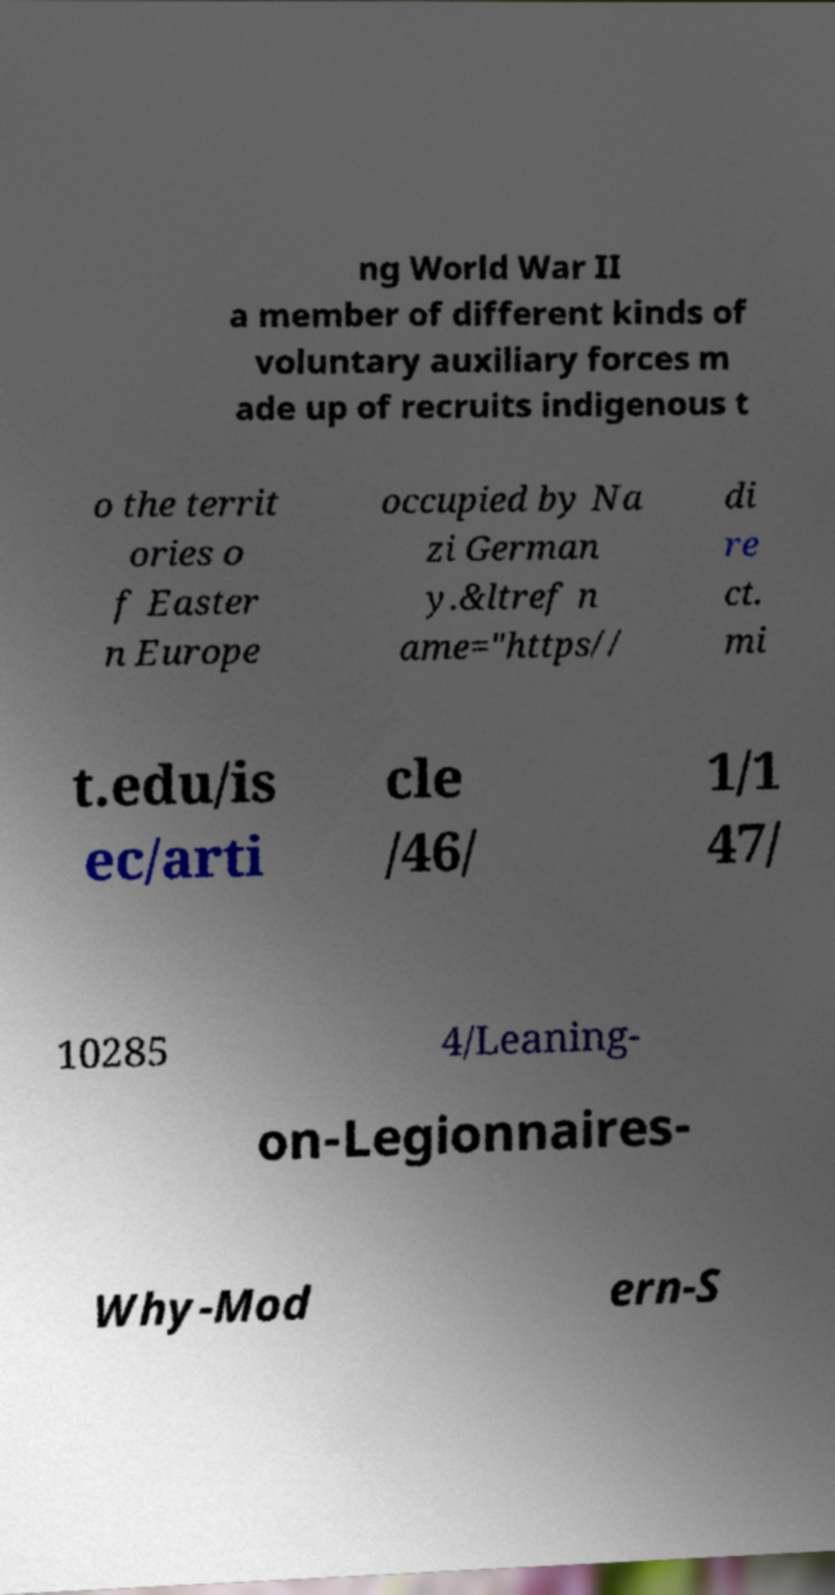Could you assist in decoding the text presented in this image and type it out clearly? ng World War II a member of different kinds of voluntary auxiliary forces m ade up of recruits indigenous t o the territ ories o f Easter n Europe occupied by Na zi German y.&ltref n ame="https// di re ct. mi t.edu/is ec/arti cle /46/ 1/1 47/ 10285 4/Leaning- on-Legionnaires- Why-Mod ern-S 